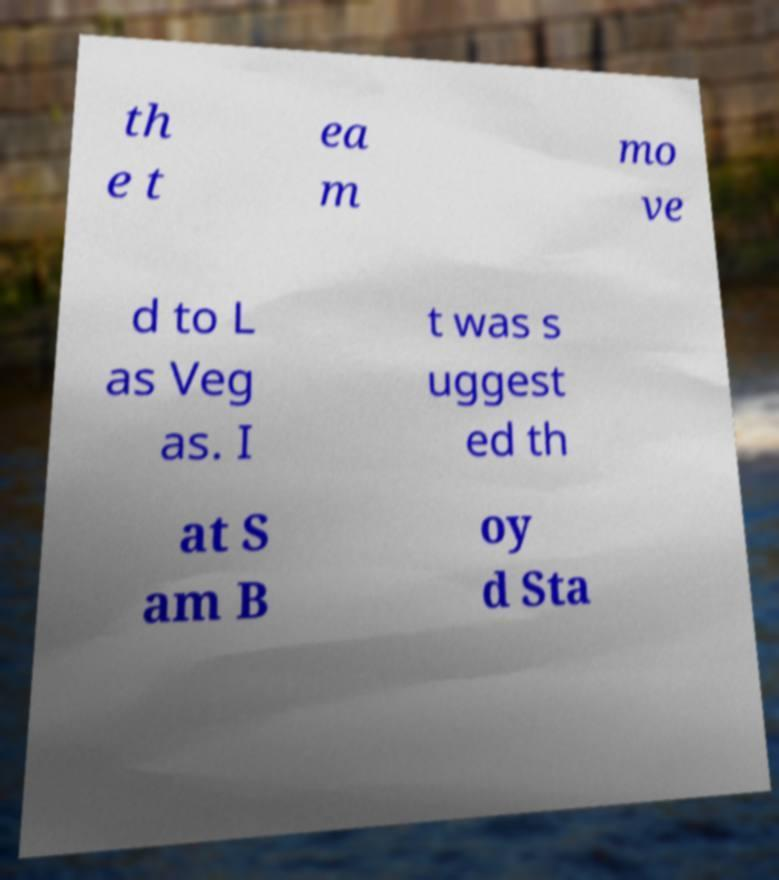There's text embedded in this image that I need extracted. Can you transcribe it verbatim? th e t ea m mo ve d to L as Veg as. I t was s uggest ed th at S am B oy d Sta 